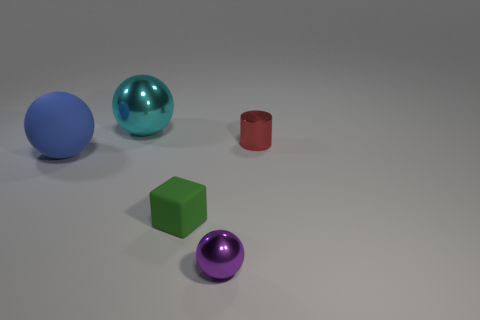Add 3 tiny cubes. How many objects exist? 8 Subtract all large balls. How many balls are left? 1 Subtract all cubes. How many objects are left? 4 Add 2 tiny green shiny blocks. How many tiny green shiny blocks exist? 2 Subtract 1 green blocks. How many objects are left? 4 Subtract 1 cylinders. How many cylinders are left? 0 Subtract all green spheres. Subtract all purple blocks. How many spheres are left? 3 Subtract all red blocks. How many blue balls are left? 1 Subtract all big cyan things. Subtract all large balls. How many objects are left? 2 Add 5 tiny purple objects. How many tiny purple objects are left? 6 